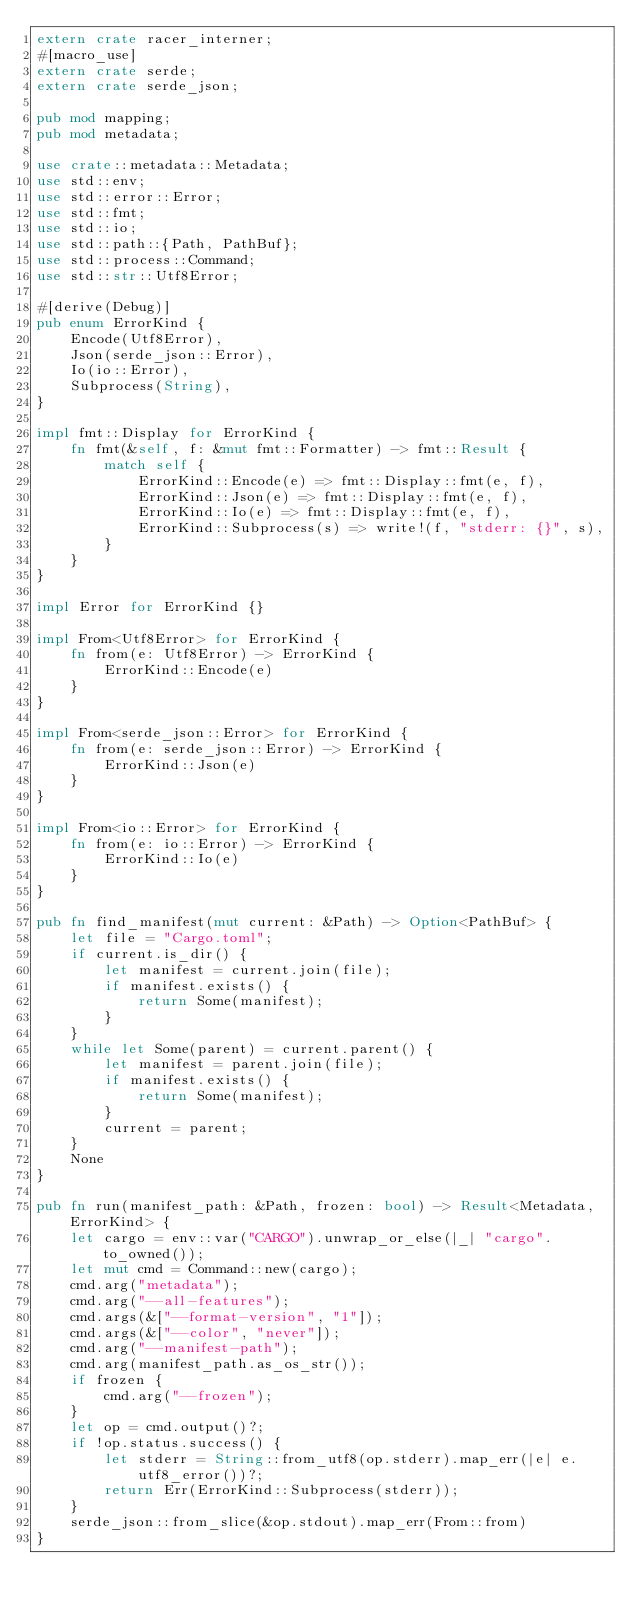<code> <loc_0><loc_0><loc_500><loc_500><_Rust_>extern crate racer_interner;
#[macro_use]
extern crate serde;
extern crate serde_json;

pub mod mapping;
pub mod metadata;

use crate::metadata::Metadata;
use std::env;
use std::error::Error;
use std::fmt;
use std::io;
use std::path::{Path, PathBuf};
use std::process::Command;
use std::str::Utf8Error;

#[derive(Debug)]
pub enum ErrorKind {
    Encode(Utf8Error),
    Json(serde_json::Error),
    Io(io::Error),
    Subprocess(String),
}

impl fmt::Display for ErrorKind {
    fn fmt(&self, f: &mut fmt::Formatter) -> fmt::Result {
        match self {
            ErrorKind::Encode(e) => fmt::Display::fmt(e, f),
            ErrorKind::Json(e) => fmt::Display::fmt(e, f),
            ErrorKind::Io(e) => fmt::Display::fmt(e, f),
            ErrorKind::Subprocess(s) => write!(f, "stderr: {}", s),
        }
    }
}

impl Error for ErrorKind {}

impl From<Utf8Error> for ErrorKind {
    fn from(e: Utf8Error) -> ErrorKind {
        ErrorKind::Encode(e)
    }
}

impl From<serde_json::Error> for ErrorKind {
    fn from(e: serde_json::Error) -> ErrorKind {
        ErrorKind::Json(e)
    }
}

impl From<io::Error> for ErrorKind {
    fn from(e: io::Error) -> ErrorKind {
        ErrorKind::Io(e)
    }
}

pub fn find_manifest(mut current: &Path) -> Option<PathBuf> {
    let file = "Cargo.toml";
    if current.is_dir() {
        let manifest = current.join(file);
        if manifest.exists() {
            return Some(manifest);
        }
    }
    while let Some(parent) = current.parent() {
        let manifest = parent.join(file);
        if manifest.exists() {
            return Some(manifest);
        }
        current = parent;
    }
    None
}

pub fn run(manifest_path: &Path, frozen: bool) -> Result<Metadata, ErrorKind> {
    let cargo = env::var("CARGO").unwrap_or_else(|_| "cargo".to_owned());
    let mut cmd = Command::new(cargo);
    cmd.arg("metadata");
    cmd.arg("--all-features");
    cmd.args(&["--format-version", "1"]);
    cmd.args(&["--color", "never"]);
    cmd.arg("--manifest-path");
    cmd.arg(manifest_path.as_os_str());
    if frozen {
        cmd.arg("--frozen");
    }
    let op = cmd.output()?;
    if !op.status.success() {
        let stderr = String::from_utf8(op.stderr).map_err(|e| e.utf8_error())?;
        return Err(ErrorKind::Subprocess(stderr));
    }
    serde_json::from_slice(&op.stdout).map_err(From::from)
}
</code> 